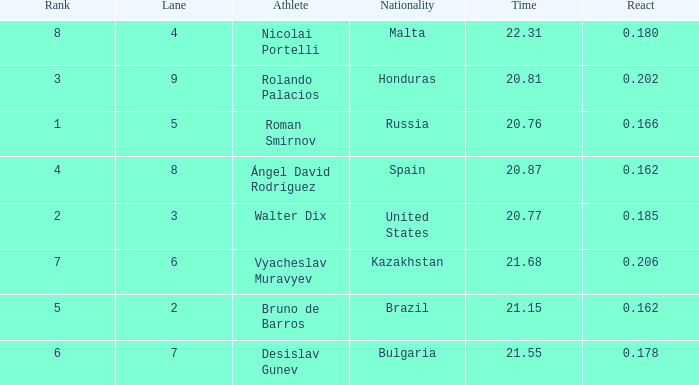What's Brazil's lane with a time less than 21.15? None. 